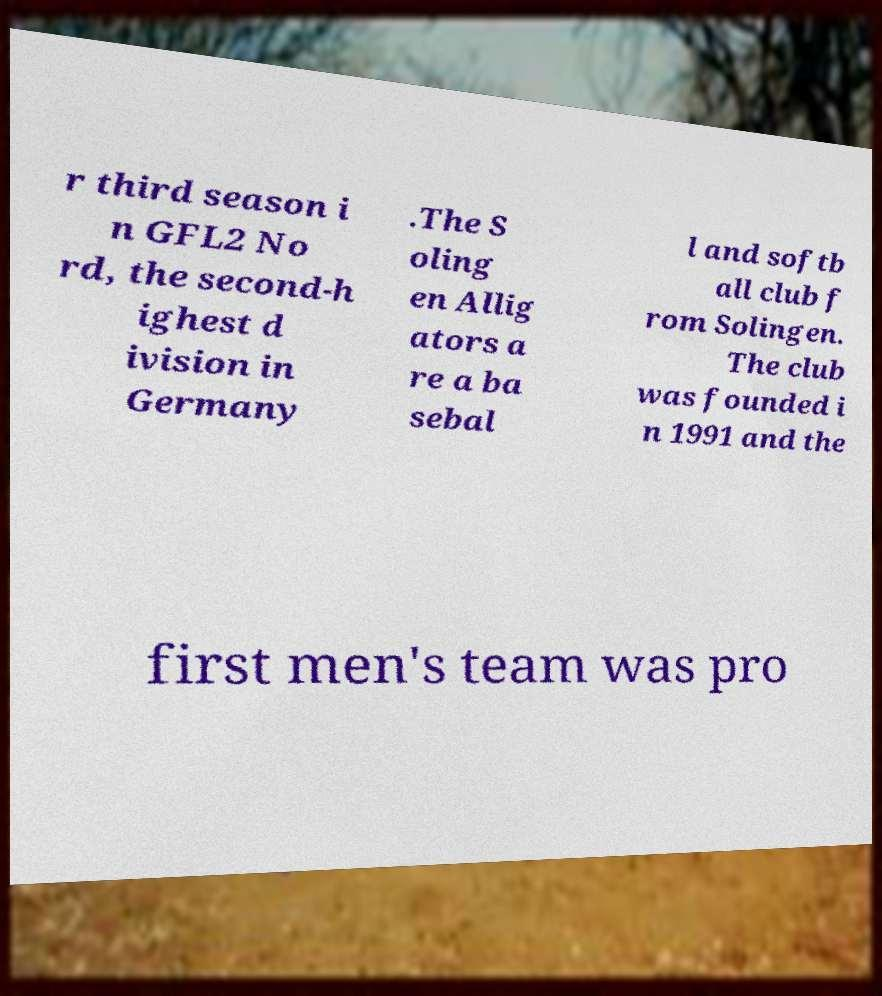Please identify and transcribe the text found in this image. r third season i n GFL2 No rd, the second-h ighest d ivision in Germany .The S oling en Allig ators a re a ba sebal l and softb all club f rom Solingen. The club was founded i n 1991 and the first men's team was pro 